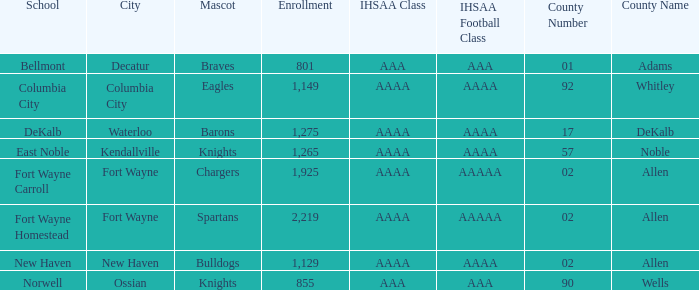What's the registration for kendallville? 1265.0. 